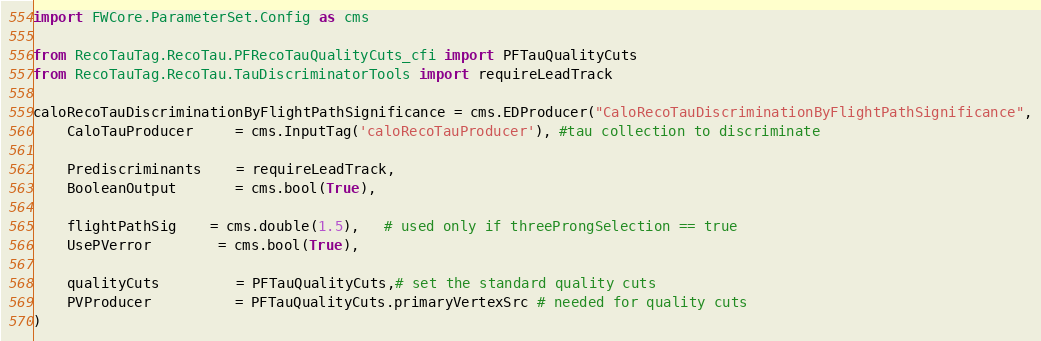Convert code to text. <code><loc_0><loc_0><loc_500><loc_500><_Python_>import FWCore.ParameterSet.Config as cms

from RecoTauTag.RecoTau.PFRecoTauQualityCuts_cfi import PFTauQualityCuts
from RecoTauTag.RecoTau.TauDiscriminatorTools import requireLeadTrack

caloRecoTauDiscriminationByFlightPathSignificance = cms.EDProducer("CaloRecoTauDiscriminationByFlightPathSignificance",
    CaloTauProducer     = cms.InputTag('caloRecoTauProducer'), #tau collection to discriminate

    Prediscriminants    = requireLeadTrack,
    BooleanOutput       = cms.bool(True),

    flightPathSig	= cms.double(1.5),   # used only if threeProngSelection == true
    UsePVerror		= cms.bool(True),

    qualityCuts         = PFTauQualityCuts,# set the standard quality cuts
    PVProducer          = PFTauQualityCuts.primaryVertexSrc # needed for quality cuts
)
</code> 